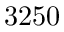<formula> <loc_0><loc_0><loc_500><loc_500>3 2 5 0</formula> 